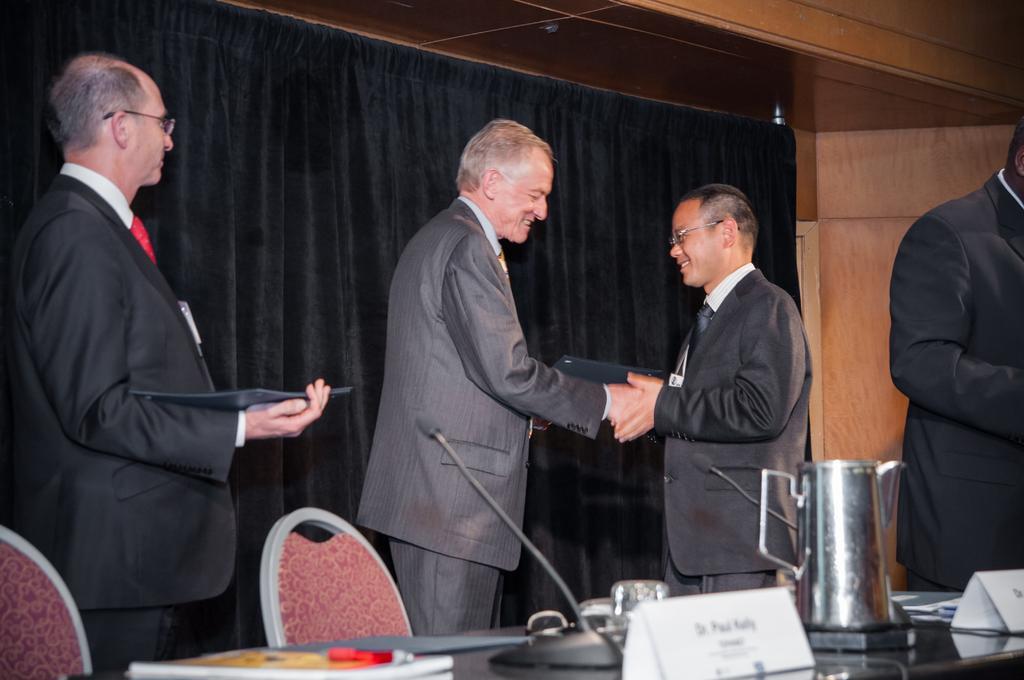Could you give a brief overview of what you see in this image? In the image there are few men in suits holding hands,standing and smiling with a table in front of them with jug,mic and books on it and in the back there is a curtain on the wall. 